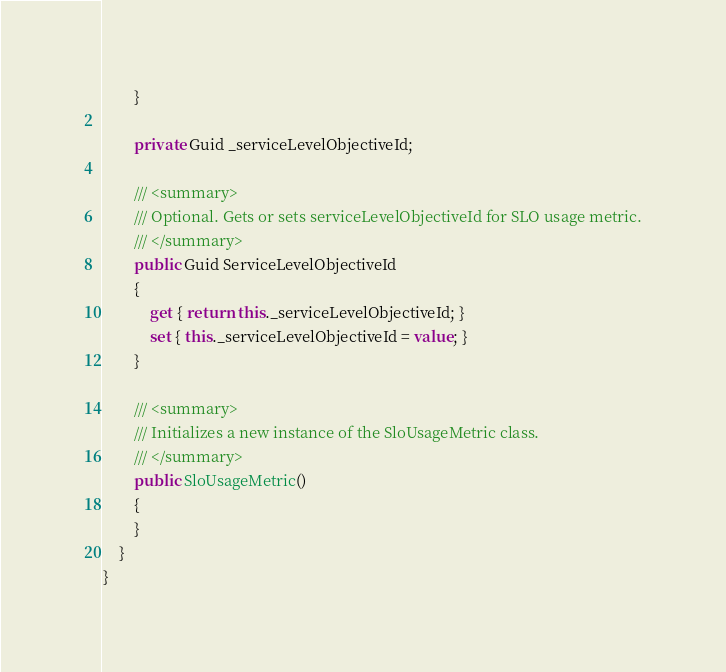<code> <loc_0><loc_0><loc_500><loc_500><_C#_>        }
        
        private Guid _serviceLevelObjectiveId;
        
        /// <summary>
        /// Optional. Gets or sets serviceLevelObjectiveId for SLO usage metric.
        /// </summary>
        public Guid ServiceLevelObjectiveId
        {
            get { return this._serviceLevelObjectiveId; }
            set { this._serviceLevelObjectiveId = value; }
        }
        
        /// <summary>
        /// Initializes a new instance of the SloUsageMetric class.
        /// </summary>
        public SloUsageMetric()
        {
        }
    }
}
</code> 